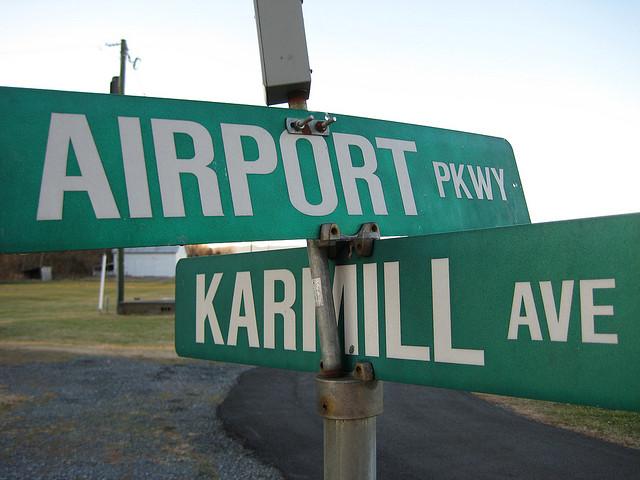Who named the roads?
Be succinct. City. What are the signs for?
Quick response, please. Street names. Is this a close up picture of the street signs?
Short answer required. Yes. 